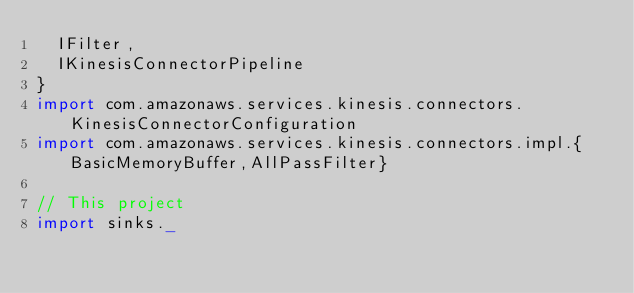<code> <loc_0><loc_0><loc_500><loc_500><_Scala_>  IFilter,
  IKinesisConnectorPipeline
}
import com.amazonaws.services.kinesis.connectors.KinesisConnectorConfiguration
import com.amazonaws.services.kinesis.connectors.impl.{BasicMemoryBuffer,AllPassFilter}

// This project
import sinks._</code> 